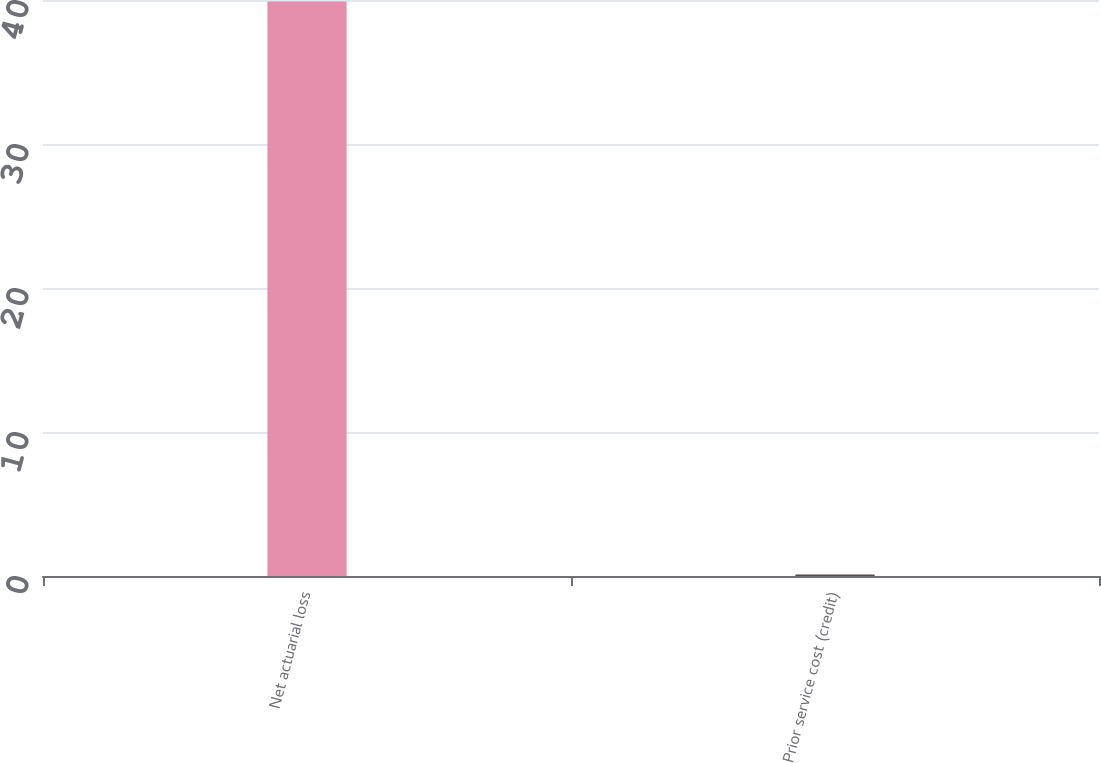Convert chart to OTSL. <chart><loc_0><loc_0><loc_500><loc_500><bar_chart><fcel>Net actuarial loss<fcel>Prior service cost (credit)<nl><fcel>39.9<fcel>0.1<nl></chart> 